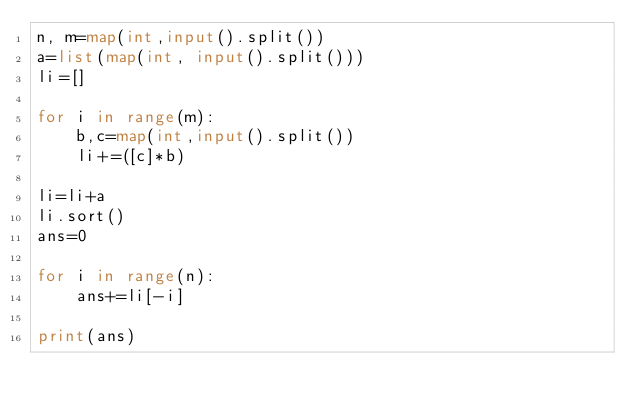<code> <loc_0><loc_0><loc_500><loc_500><_Python_>n, m=map(int,input().split())
a=list(map(int, input().split()))
li=[]

for i in range(m):
    b,c=map(int,input().split())
    li+=([c]*b)

li=li+a
li.sort()
ans=0

for i in range(n):
    ans+=li[-i]

print(ans)
</code> 